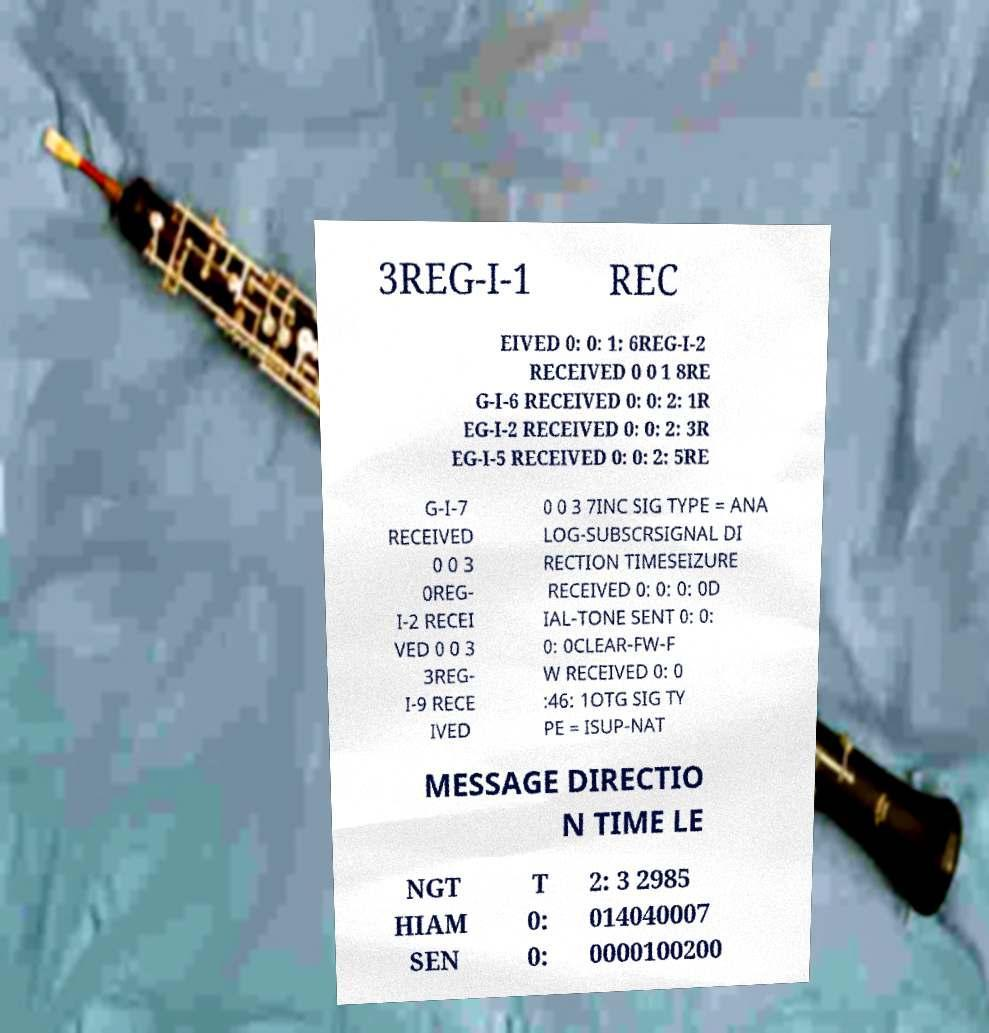For documentation purposes, I need the text within this image transcribed. Could you provide that? 3REG-I-1 REC EIVED 0: 0: 1: 6REG-I-2 RECEIVED 0 0 1 8RE G-I-6 RECEIVED 0: 0: 2: 1R EG-I-2 RECEIVED 0: 0: 2: 3R EG-I-5 RECEIVED 0: 0: 2: 5RE G-I-7 RECEIVED 0 0 3 0REG- I-2 RECEI VED 0 0 3 3REG- I-9 RECE IVED 0 0 3 7INC SIG TYPE = ANA LOG-SUBSCRSIGNAL DI RECTION TIMESEIZURE RECEIVED 0: 0: 0: 0D IAL-TONE SENT 0: 0: 0: 0CLEAR-FW-F W RECEIVED 0: 0 :46: 1OTG SIG TY PE = ISUP-NAT MESSAGE DIRECTIO N TIME LE NGT HIAM SEN T 0: 0: 2: 3 2985 014040007 0000100200 